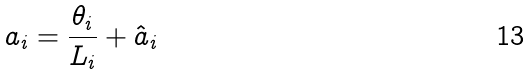Convert formula to latex. <formula><loc_0><loc_0><loc_500><loc_500>a _ { i } = \frac { \theta _ { i } } { L _ { i } } + \hat { a } _ { i }</formula> 